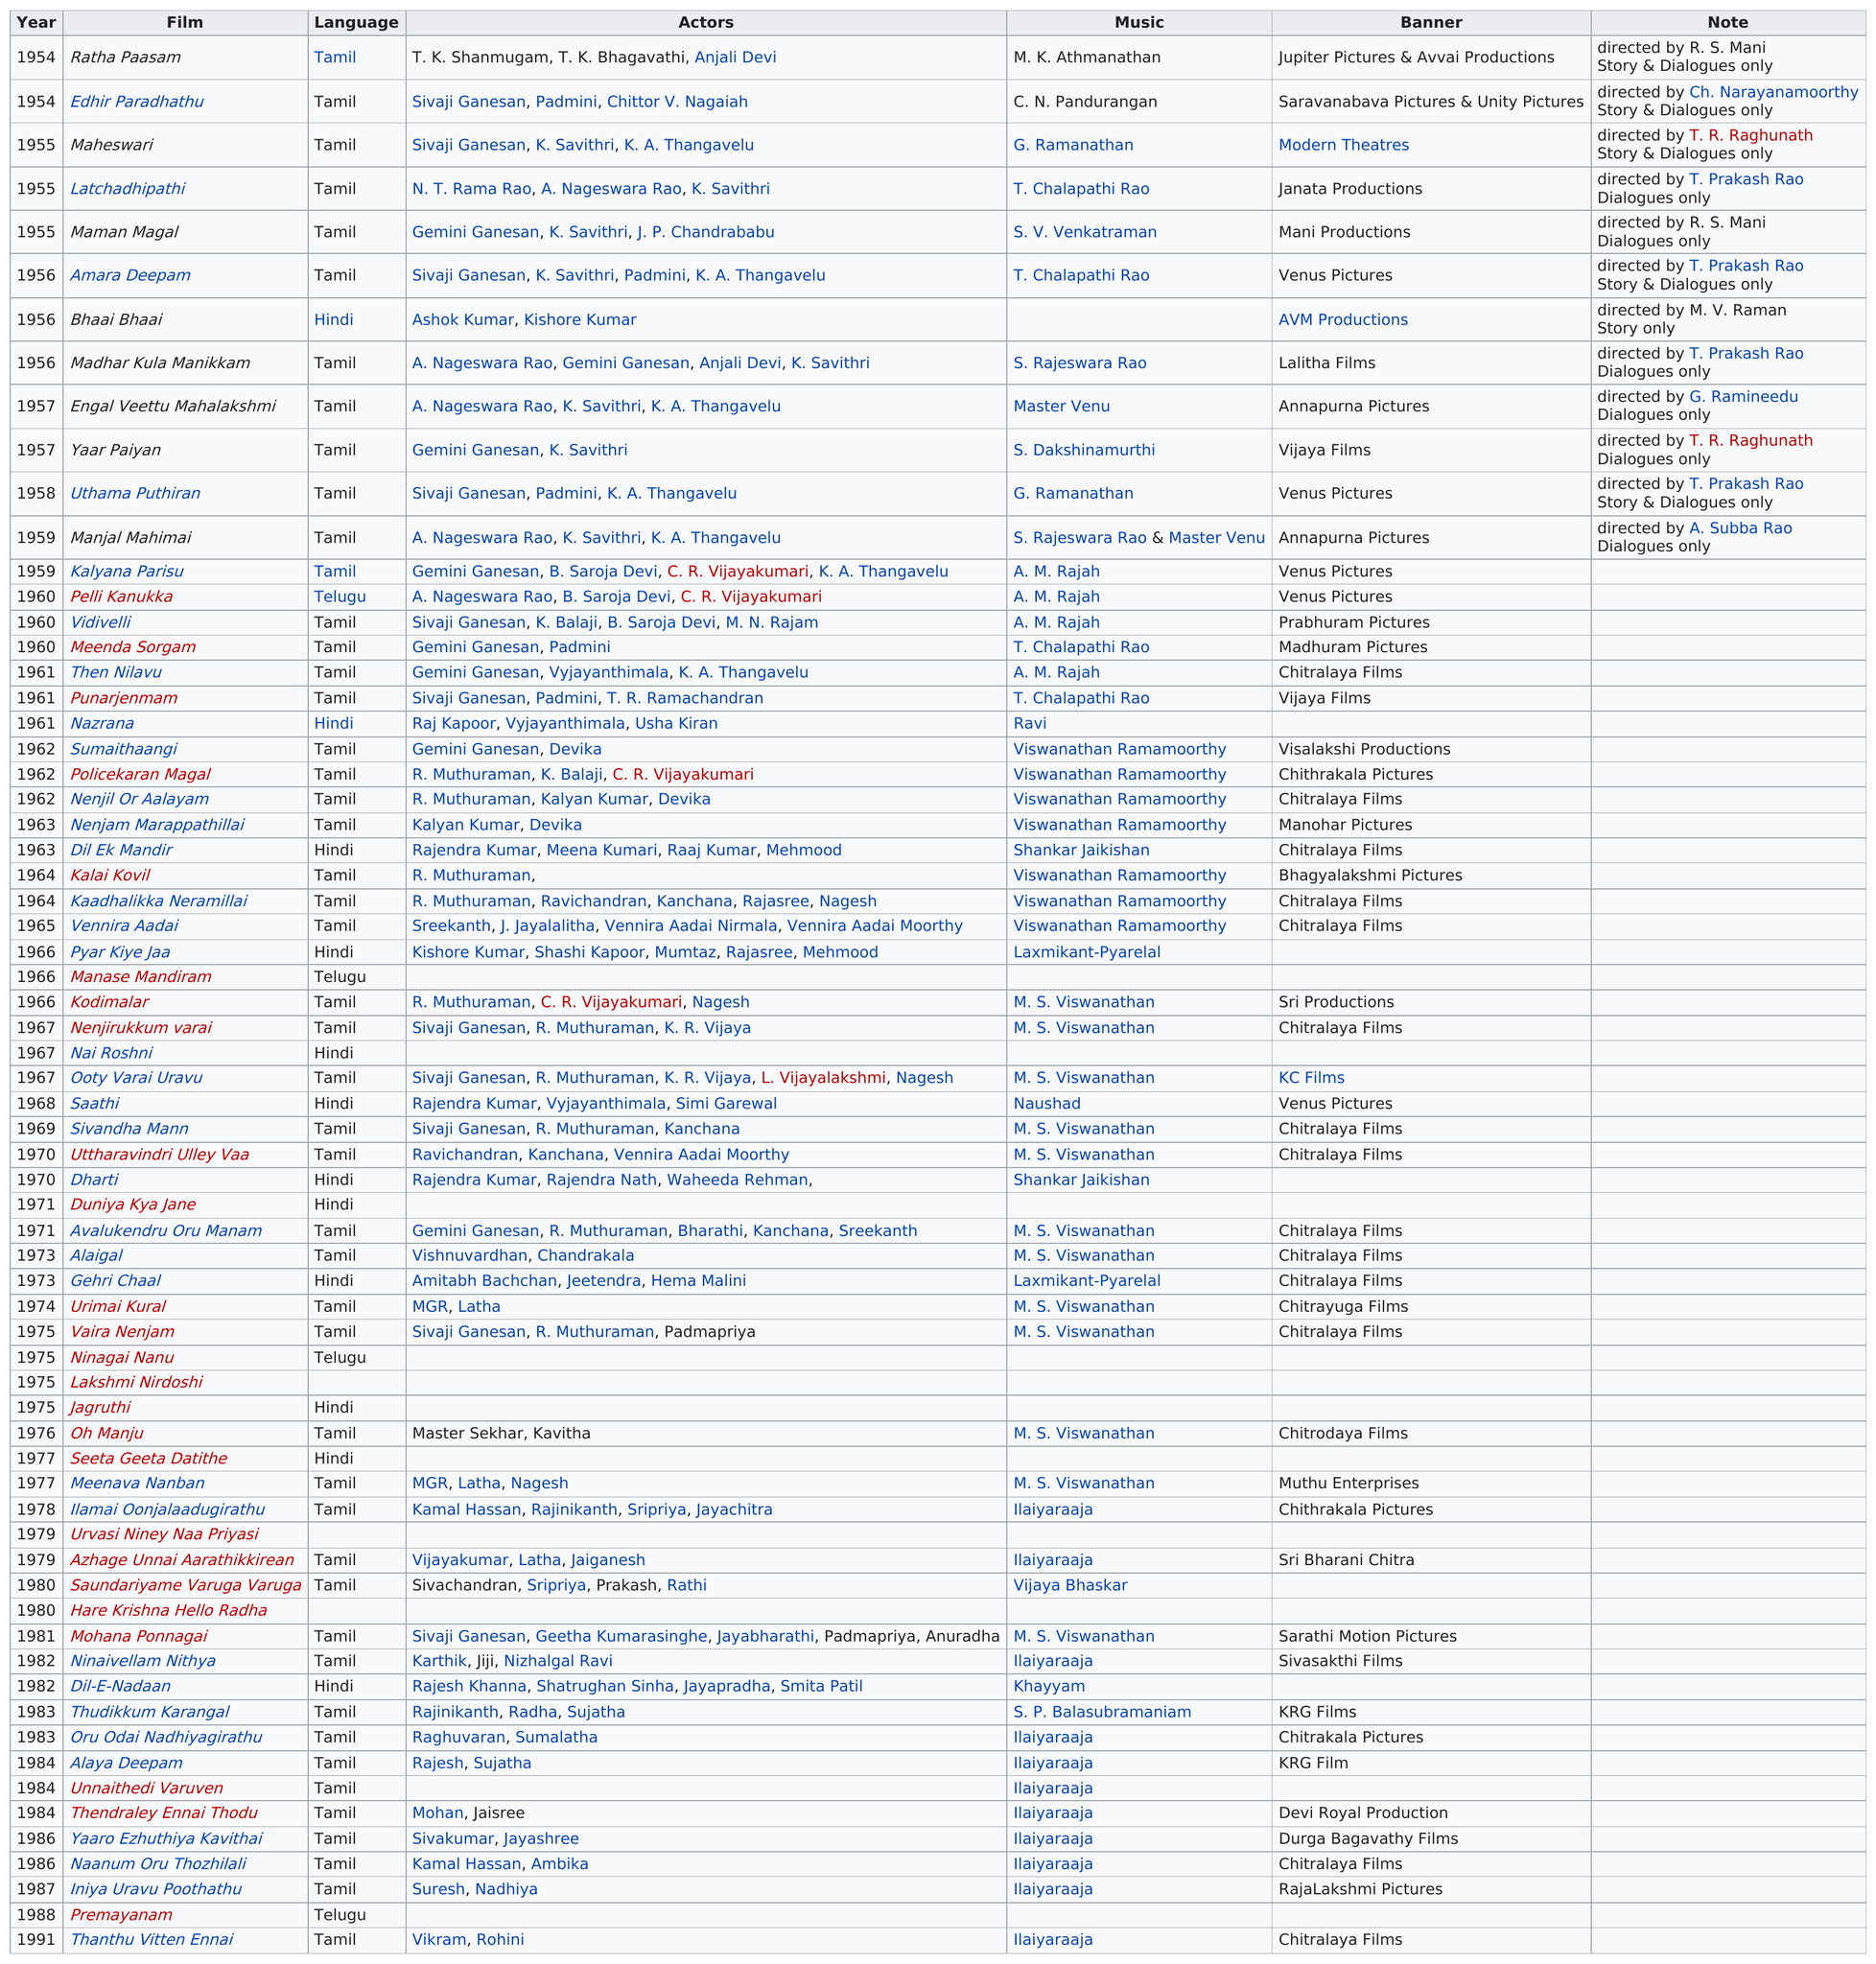Highlight a few significant elements in this photo. C. V. Sridhar directed and wrote 22 films in the 1960s. C.V. Sridhar directed 24 movies between 1960 and 1970. M. S. Viswanathan wrote the most music for C. V. Sridhar's movies. M.S. Viswanathan did the music for a total of 12 movies. After 1961, Sridhar directed 48 films. 